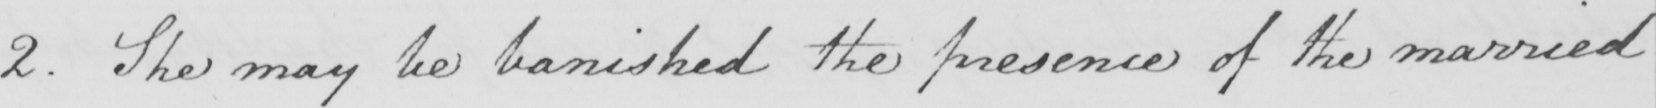What does this handwritten line say? 2 . She may be banished the presence of the married 